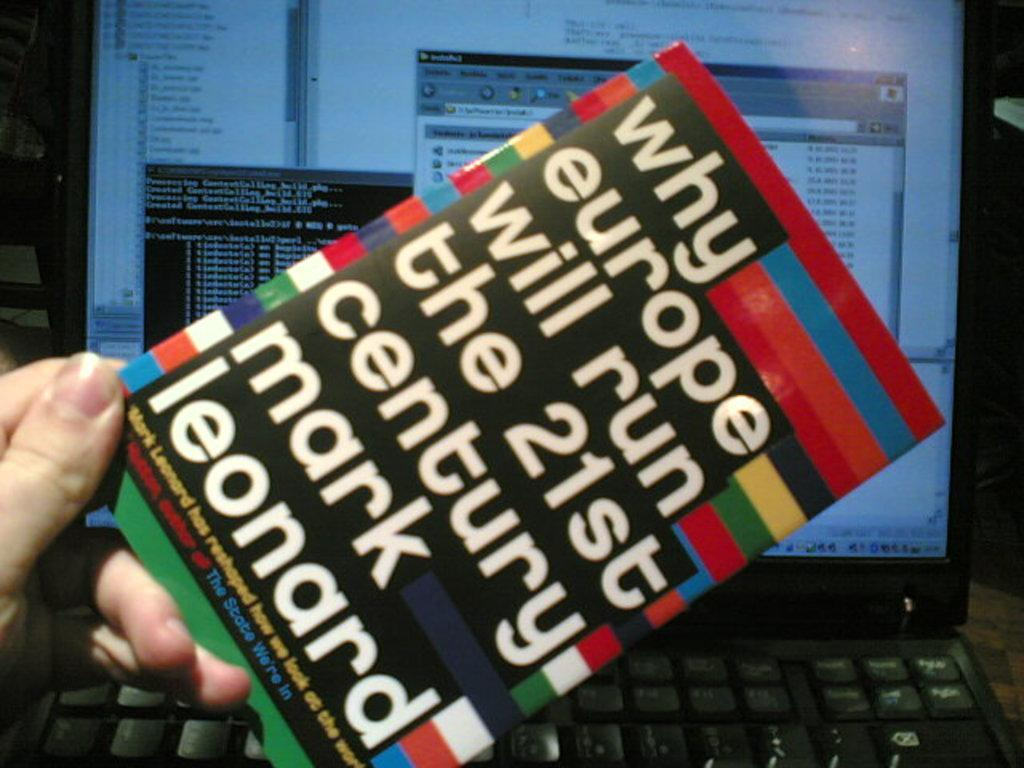<image>
Create a compact narrative representing the image presented. A person holding a book titled "Why Europe will run the 21st century" by Mark Leonard 